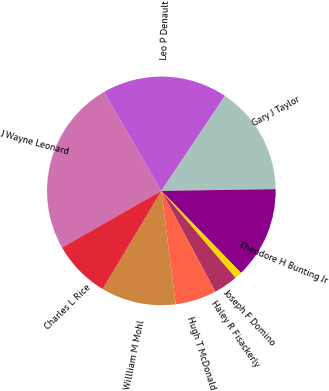<chart> <loc_0><loc_0><loc_500><loc_500><pie_chart><fcel>J Wayne Leonard<fcel>Leo P Denault<fcel>Gary J Taylor<fcel>Theodore H Bunting Jr<fcel>Joseph F Domino<fcel>Haley R Fisackerly<fcel>Hugh T McDonald<fcel>Willliam M Mohl<fcel>Charles L Rice<nl><fcel>24.9%<fcel>17.74%<fcel>15.36%<fcel>12.97%<fcel>1.03%<fcel>3.42%<fcel>5.81%<fcel>10.58%<fcel>8.19%<nl></chart> 